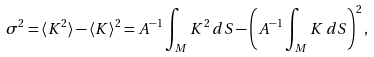Convert formula to latex. <formula><loc_0><loc_0><loc_500><loc_500>\sigma ^ { 2 } = \langle K ^ { 2 } \rangle - \langle K \rangle ^ { 2 } = A ^ { - 1 } \int _ { M } K ^ { 2 } \, d S - \left ( A ^ { - 1 } \int _ { M } K \, d S \right ) ^ { 2 } ,</formula> 